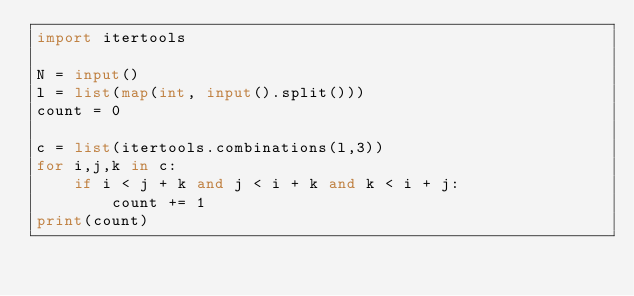Convert code to text. <code><loc_0><loc_0><loc_500><loc_500><_Python_>import itertools

N = input()
l = list(map(int, input().split()))
count = 0

c = list(itertools.combinations(l,3))
for i,j,k in c:
    if i < j + k and j < i + k and k < i + j:
        count += 1
print(count)</code> 